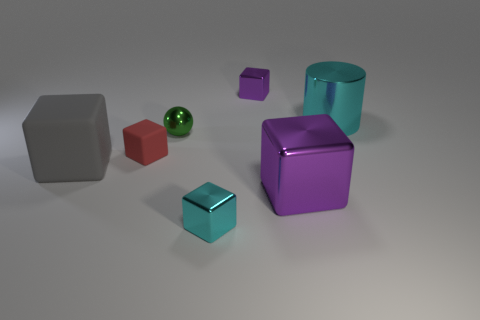There is a purple object that is in front of the red matte cube; what is its size?
Make the answer very short. Large. Are there fewer large cyan shiny cylinders that are in front of the gray object than big rubber things?
Ensure brevity in your answer.  Yes. Is the color of the tiny rubber cube the same as the cylinder?
Your answer should be very brief. No. Are there any other things that are the same shape as the small purple shiny object?
Provide a succinct answer. Yes. Is the number of brown rubber spheres less than the number of big metal blocks?
Your answer should be compact. Yes. What is the color of the cube on the right side of the purple metallic thing that is behind the big cyan metal object?
Keep it short and to the point. Purple. There is a purple cube that is to the right of the small shiny cube behind the rubber thing behind the large matte object; what is its material?
Provide a short and direct response. Metal. Is the size of the matte block on the left side of the red matte thing the same as the small cyan object?
Give a very brief answer. No. What is the material of the purple object that is in front of the green shiny object?
Provide a short and direct response. Metal. Is the number of purple cubes greater than the number of metal cubes?
Provide a succinct answer. No. 